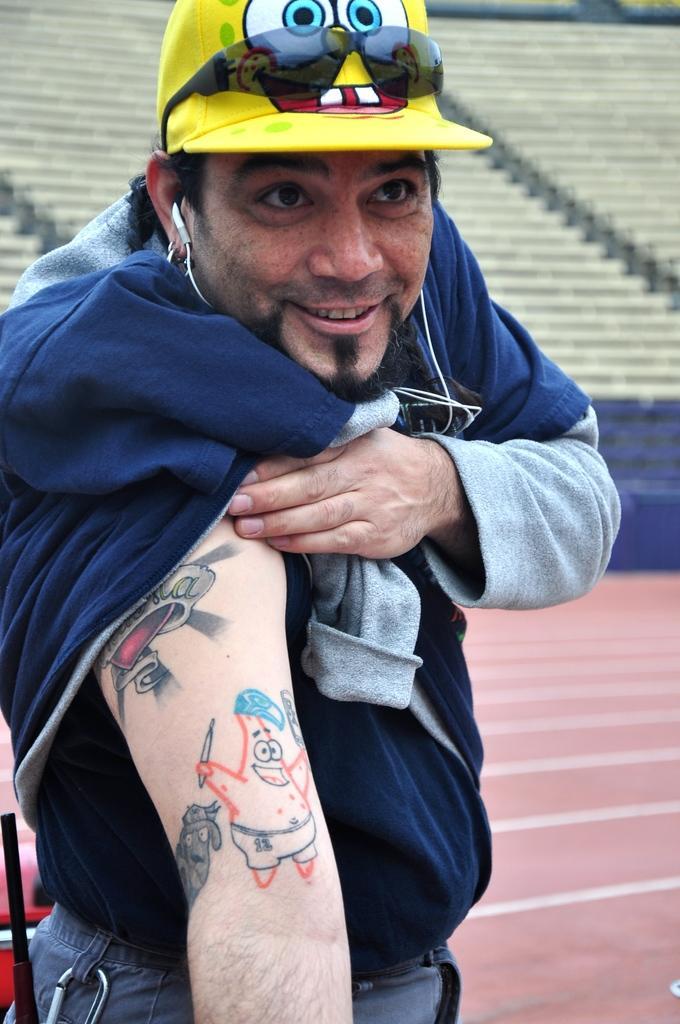In one or two sentences, can you explain what this image depicts? In this image we can see a person standing on the ground wearing a hat, glasses and a headset. On the backside we can a stadium seating. 